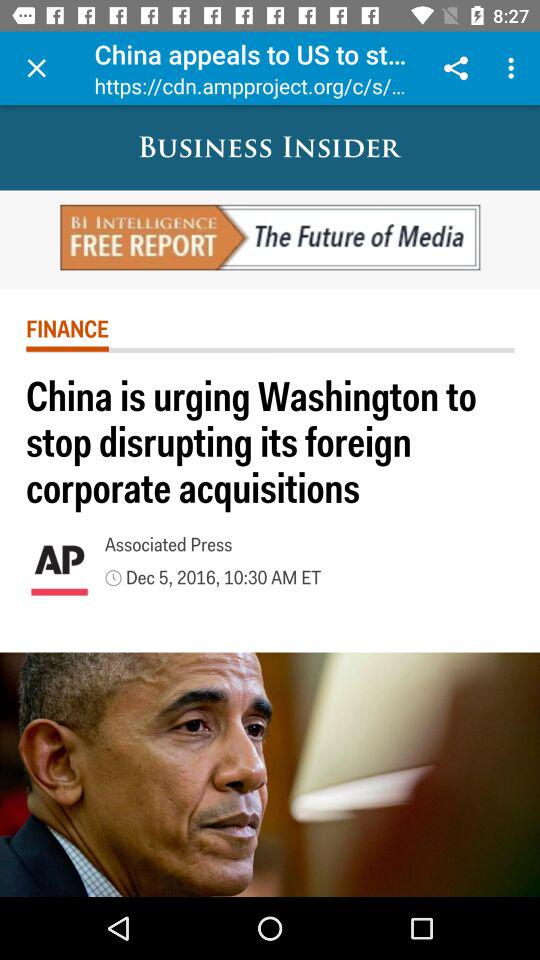Tell me the name of the press who published this article? The press who published this article is the Associated Press. 